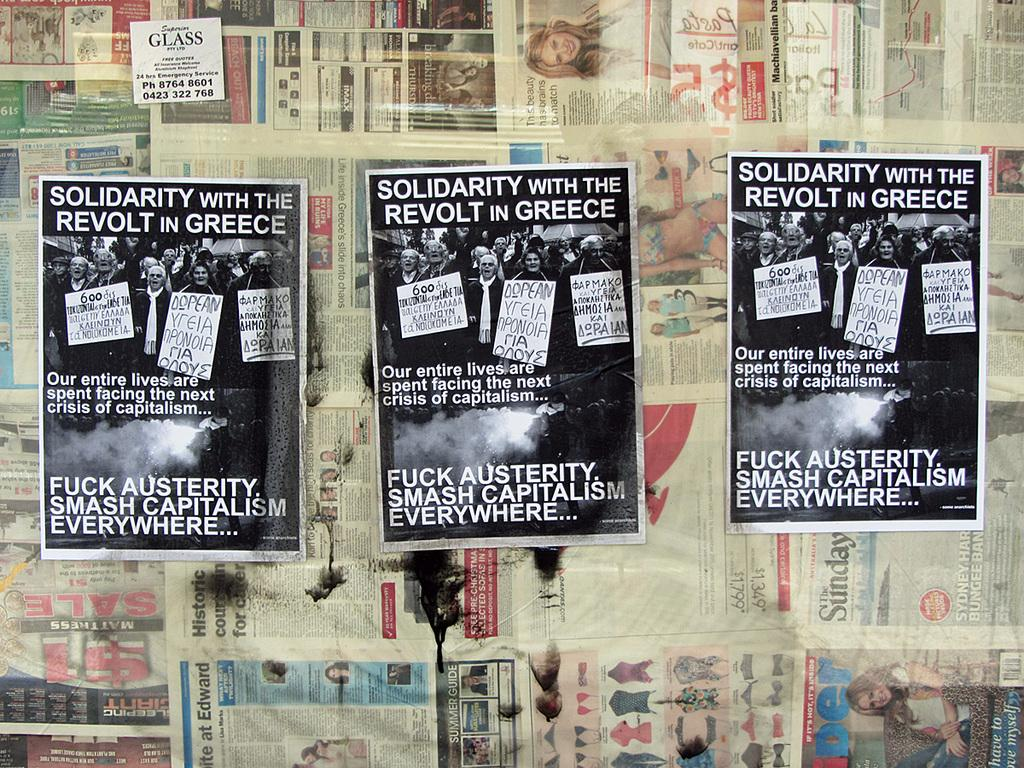What type of printed material is present in the image? The image contains many newspapers. What can be found on the newspapers? The newspapers have images and text on them. What else is present in the middle of the image besides newspapers? There are three posters in the middle of the image. What do the posters have in common with the newspapers? The posters also have images and text on them. What type of crook can be seen attacking the posters in the image? There is no crook or attack present in the image; it only contains newspapers and posters with images and text. 